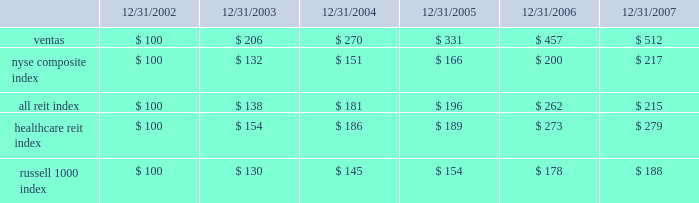Stock performance graph the following performance graph compares the cumulative total return ( including dividends ) to the holders of our common stock from december 31 , 2002 through december 31 , 2007 , with the cumulative total returns of the nyse composite index , the ftse nareit composite reit index ( the 201call reit index 201d ) , the ftse nareit healthcare equity reit index ( the 201chealthcare reit index 201d ) and the russell 1000 index over the same period .
The comparison assumes $ 100 was invested on december 31 , 2002 in our common stock and in each of the foregoing indices and assumes reinvestment of dividends , as applicable .
We have included the nyse composite index in the performance graph because our common stock is listed on the nyse .
We have included the other indices because we believe that they are either most representative of the industry in which we compete , or otherwise provide a fair basis for comparison with ventas , and are therefore particularly relevant to an assessment of our performance .
The figures in the table below are rounded to the nearest dollar. .
Ventas nyse composite index all reit index healthcare reit index russell 1000 index .
What was the 5 year return on the nyse composite index? 
Computations: ((217 - 100) / 100)
Answer: 1.17. 